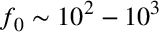<formula> <loc_0><loc_0><loc_500><loc_500>f _ { 0 } \sim 1 0 ^ { 2 } - 1 0 ^ { 3 }</formula> 